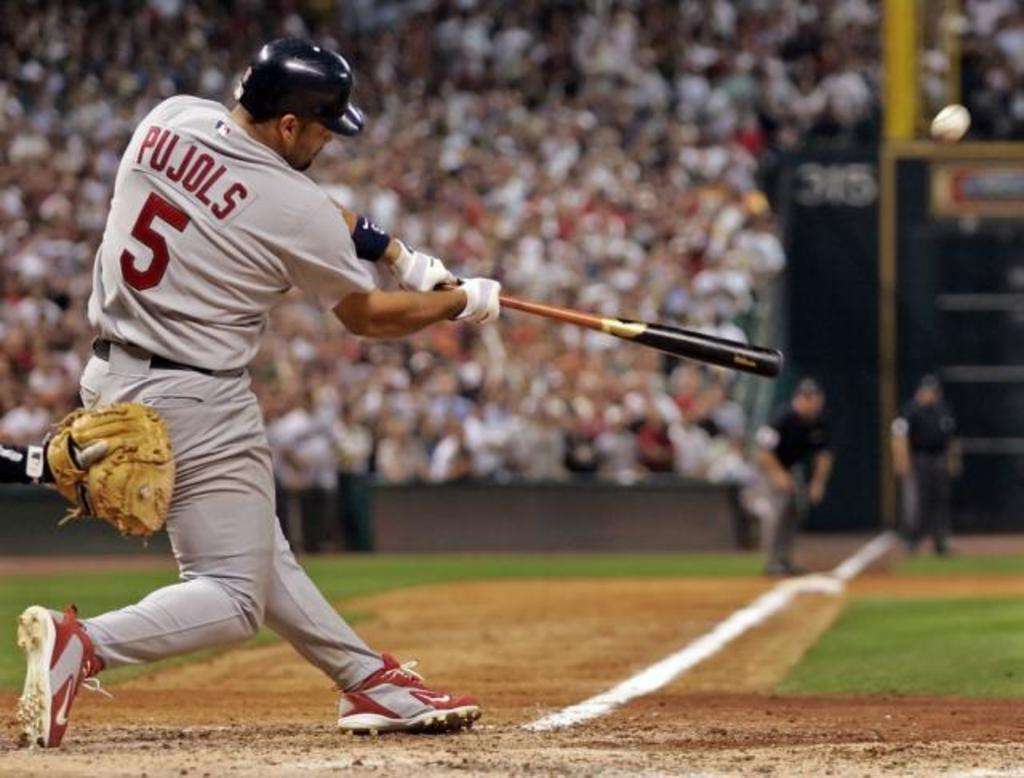<image>
Render a clear and concise summary of the photo. Pujols, a baseball player,wearing number 5,  strikes the ball. 